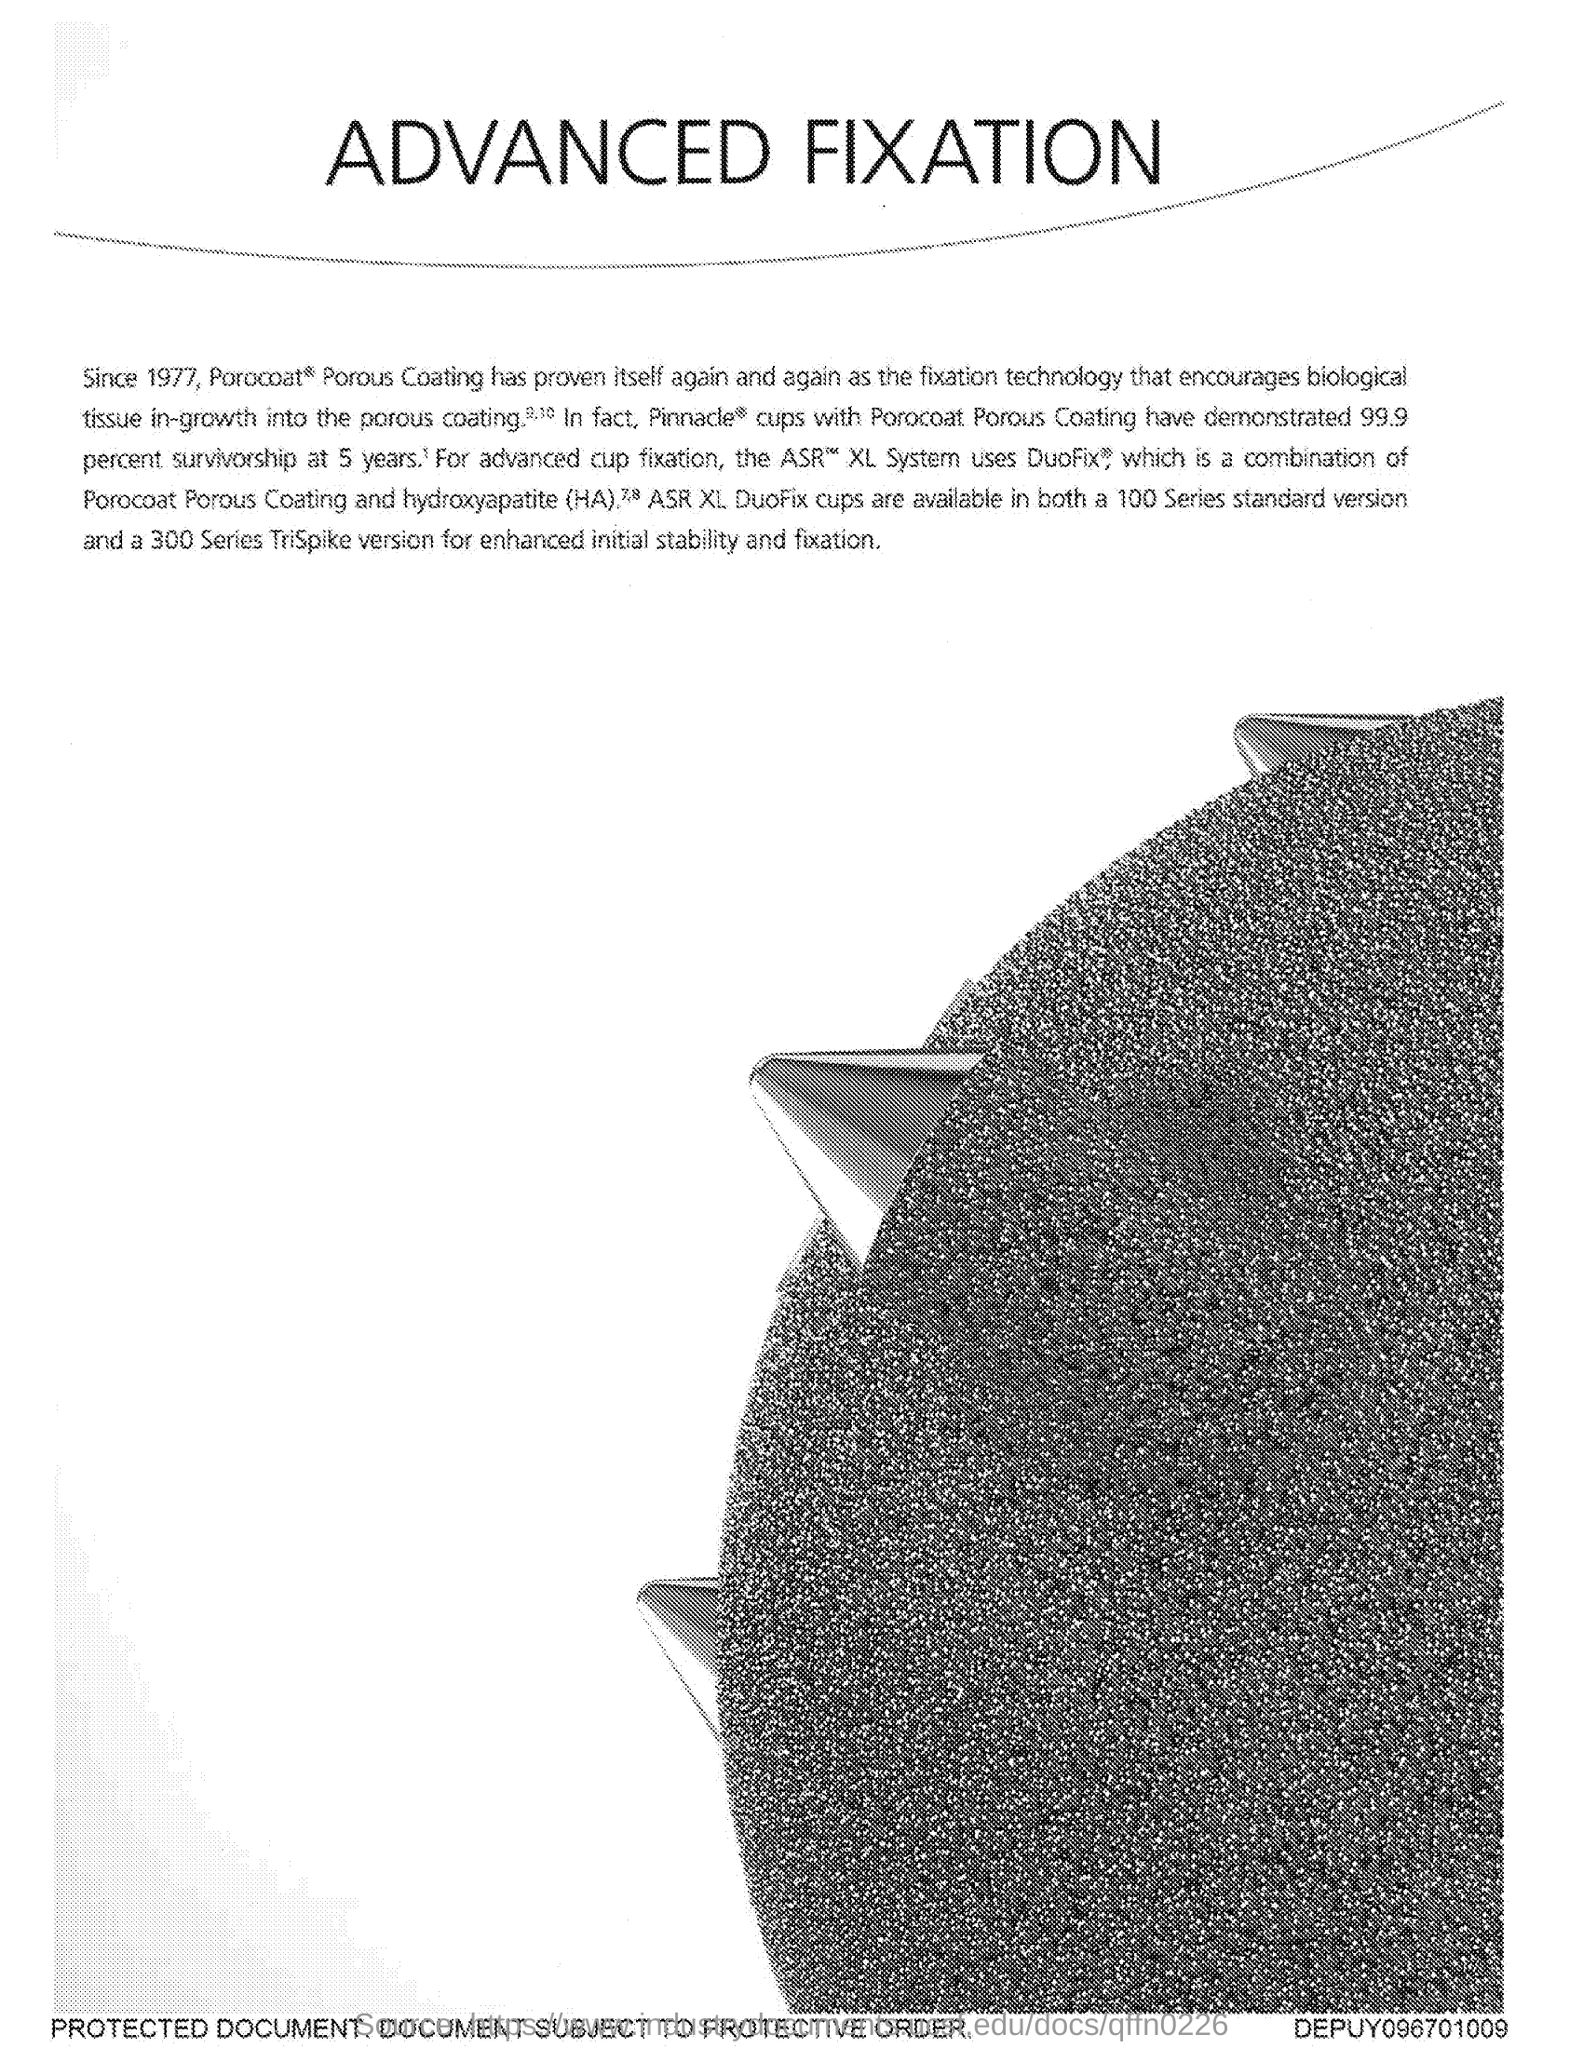What is the title of the document?
Your response must be concise. Advanced Fixation. 